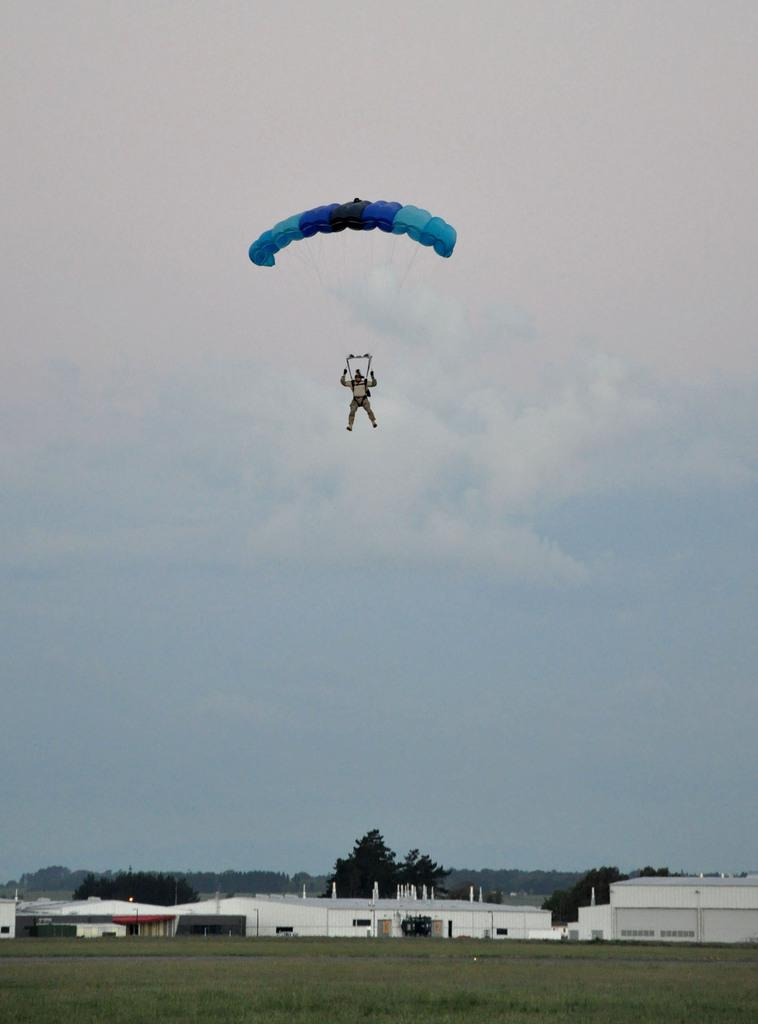What is the person in the image doing? The person in the image is flying with the help of a parachute. What can be seen in the background of the image? There are houses and trees in the image. How is the sky depicted in the image? The sky is clouded in the image. What type of knife is being used to cut the tree in the image? There is no knife or tree-cutting activity present in the image. Can you describe the detail of the stove in the image? There is no stove present in the image. 